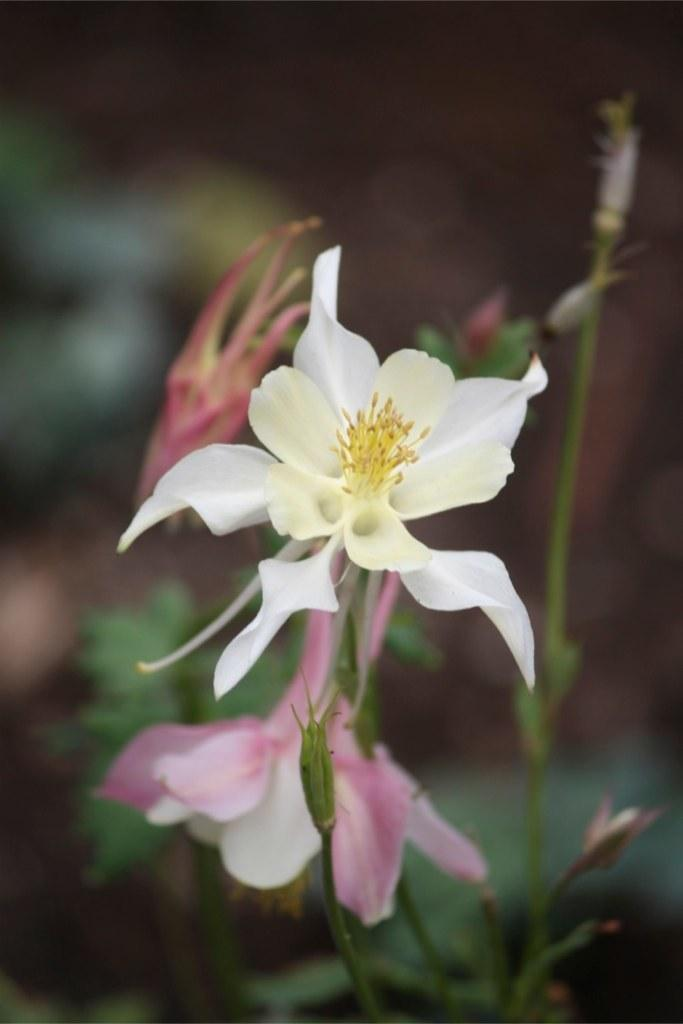What is present in the image? There is a plant in the image. What specific features can be observed on the plant? The plant has flowers and buds. Can you describe the background of the image? The background of the image is blurred. What type of apparatus is used to water the plant in the image? There is no apparatus visible in the image; it only shows the plant with flowers and buds. What belief system is associated with the plant in the image? There is no indication of any belief system associated with the plant in the image. 